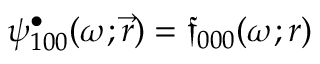Convert formula to latex. <formula><loc_0><loc_0><loc_500><loc_500>{ \psi _ { 1 0 0 } ^ { \bullet } ( \omega ; \vec { r } ) = \mathfrak { f } _ { 0 0 0 } ( \omega ; r ) }</formula> 